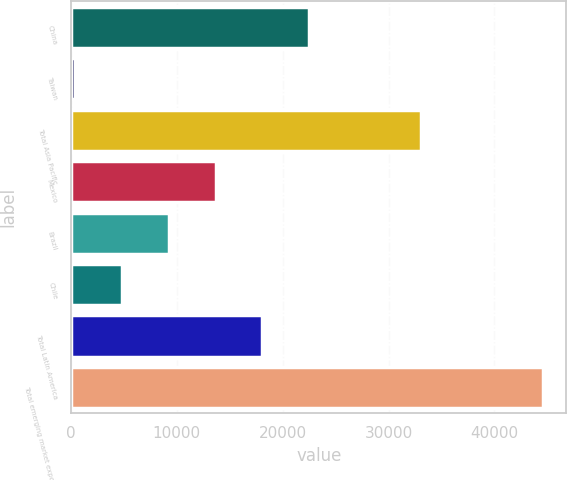Convert chart. <chart><loc_0><loc_0><loc_500><loc_500><bar_chart><fcel>China<fcel>Taiwan<fcel>Total Asia Pacific<fcel>Mexico<fcel>Brazil<fcel>Chile<fcel>Total Latin America<fcel>Total emerging market exposure<nl><fcel>22498.5<fcel>419<fcel>33043<fcel>13666.7<fcel>9250.8<fcel>4834.9<fcel>18082.6<fcel>44578<nl></chart> 